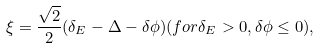<formula> <loc_0><loc_0><loc_500><loc_500>\xi = \frac { \sqrt { 2 } } { 2 } ( \delta _ { E } - \Delta - \delta \phi ) ( f o r \delta _ { E } > 0 , \delta \phi \leq 0 ) ,</formula> 